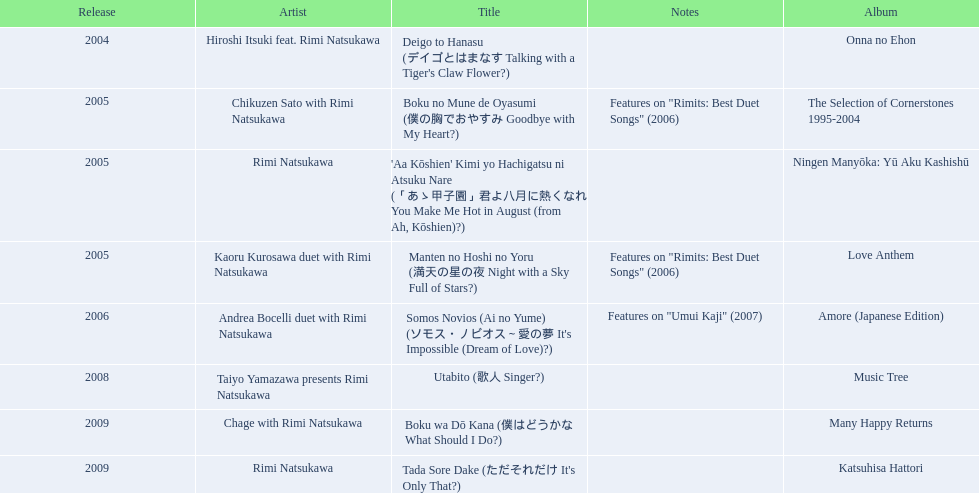What are the chords for a sky full of stars? Features on "Rimits: Best Duet Songs" (2006). What additional song has these same chords? Boku no Mune de Oyasumi (僕の胸でおやすみ Goodbye with My Heart?). 